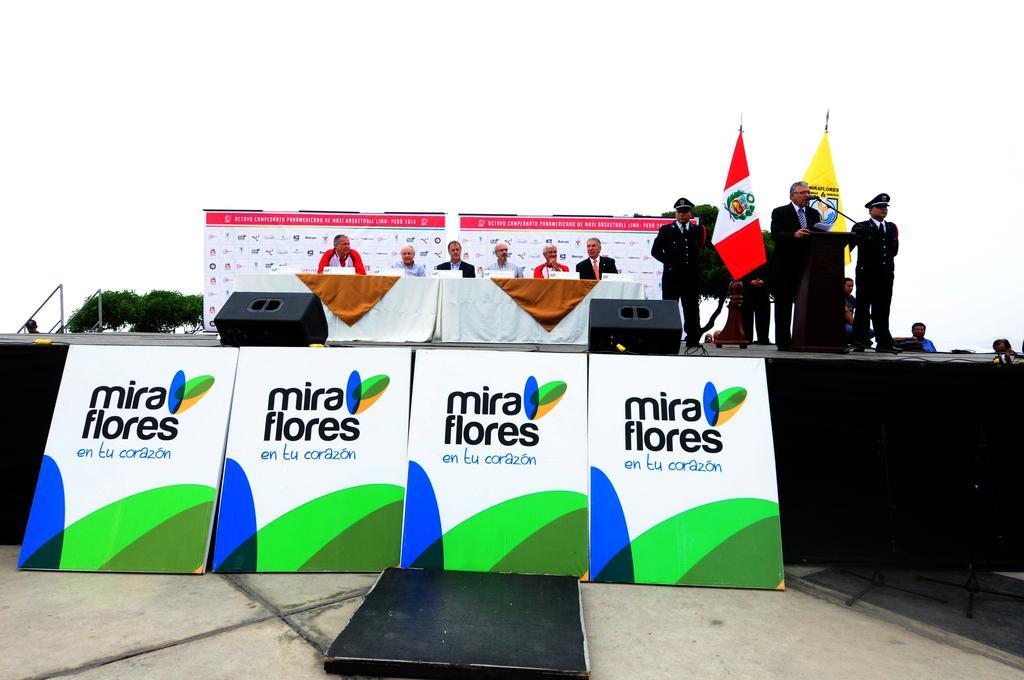How would you summarize this image in a sentence or two? In this picture there are group of people sitting behind the tables and the tables are covered with white color and there are objects on the tables. There are group of people standing at the stage at the podium and there are flags, hoardings and speakers on the stage. In the foreground there are hoardings and there is a text on the hoardings. On the left side of the image there is a handrail and there is a tree. At the top there is sky. 